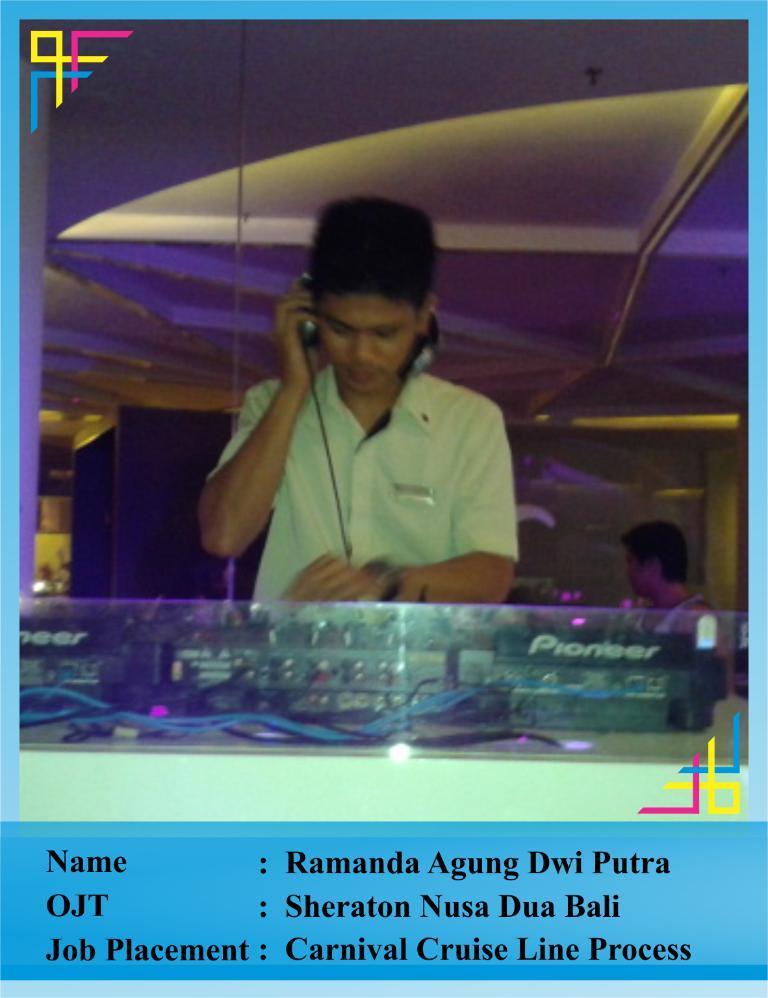Can you describe this image briefly? This is an edited image with the borders. In the center there is a person wearing headphones, standing and seems to be working. In the foreground we can see some instruments. In the background we can see another person and we can see many other objects. At the top there is a roof. A the bottom we can see the text on the image. 